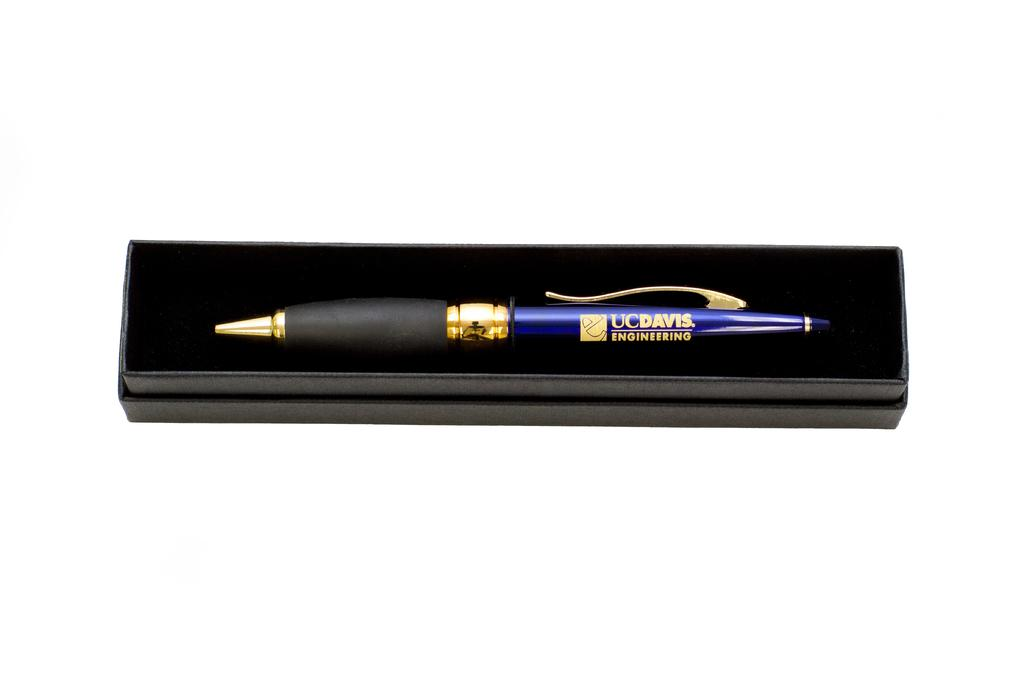What object is present in the image? There is a pen in the image. Where is the pen located? The pen is in a box. What is the color of the box? The box is black in color. What is the surface beneath the box? The box is on a white surface. What can be found on the pen? There is text on the pen. Can you see the fang of the snake in the image? There is no snake or fang present in the image; it only features a pen in a box. 